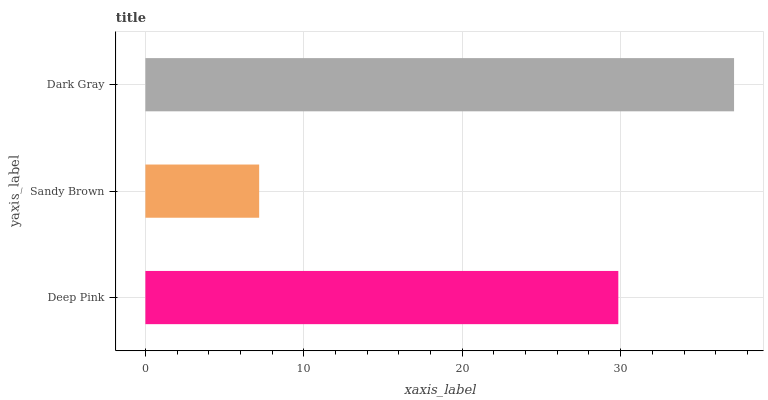Is Sandy Brown the minimum?
Answer yes or no. Yes. Is Dark Gray the maximum?
Answer yes or no. Yes. Is Dark Gray the minimum?
Answer yes or no. No. Is Sandy Brown the maximum?
Answer yes or no. No. Is Dark Gray greater than Sandy Brown?
Answer yes or no. Yes. Is Sandy Brown less than Dark Gray?
Answer yes or no. Yes. Is Sandy Brown greater than Dark Gray?
Answer yes or no. No. Is Dark Gray less than Sandy Brown?
Answer yes or no. No. Is Deep Pink the high median?
Answer yes or no. Yes. Is Deep Pink the low median?
Answer yes or no. Yes. Is Dark Gray the high median?
Answer yes or no. No. Is Dark Gray the low median?
Answer yes or no. No. 